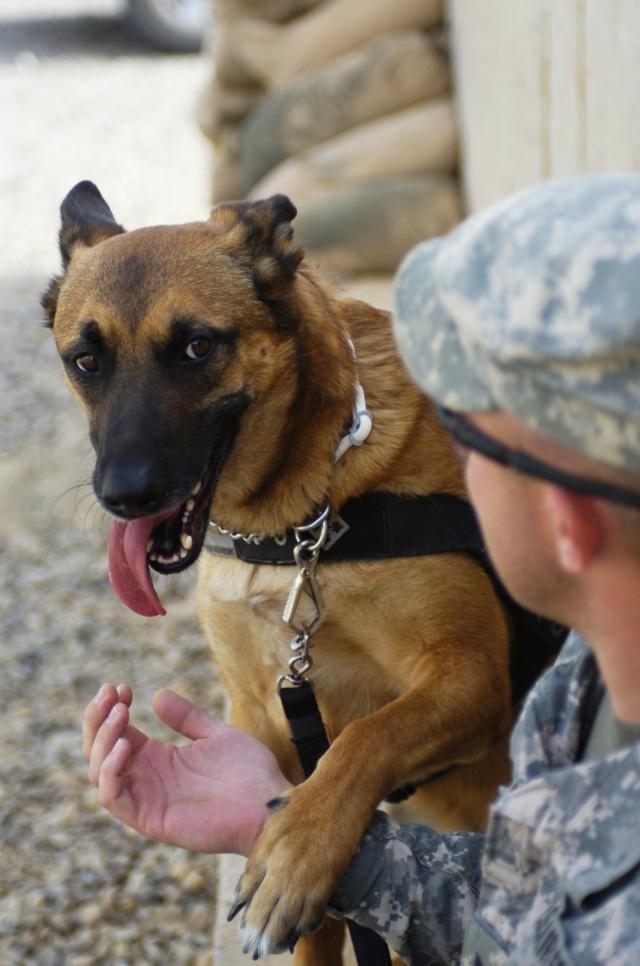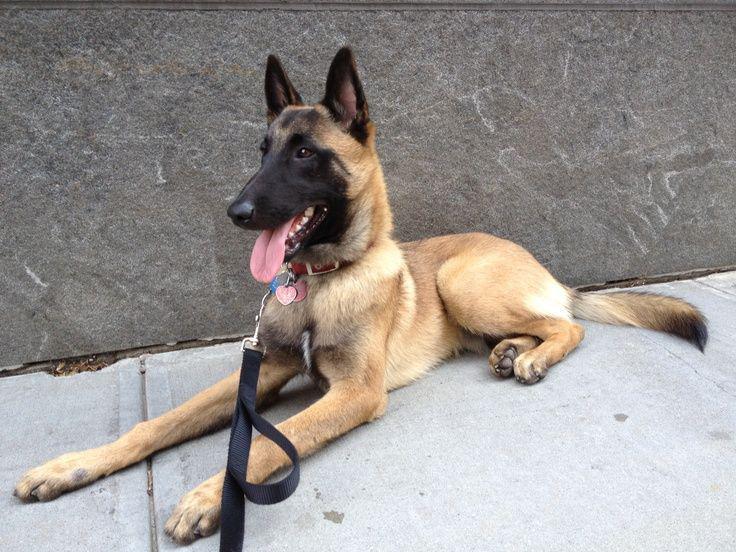The first image is the image on the left, the second image is the image on the right. Analyze the images presented: Is the assertion "No human is visible next to the german shepherd dog in the right image." valid? Answer yes or no. Yes. The first image is the image on the left, the second image is the image on the right. Assess this claim about the two images: "A dog is lying on the cement in one of the images.". Correct or not? Answer yes or no. Yes. 